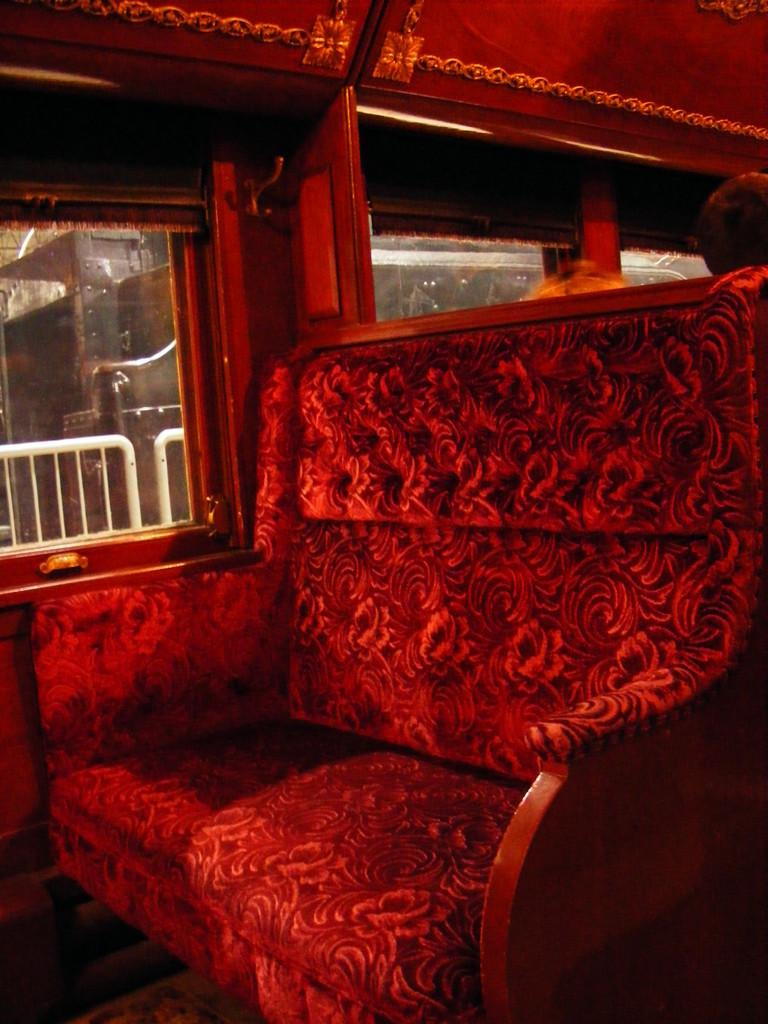What type of furniture is present in the image? There is a sofa in the image. What color is the sofa? The sofa is red in color. What can be seen through the windows in the image? The facts provided do not mention anything about the windows, so we cannot determine what can be seen through them. What type of soup is being served on the red sofa in the image? There is no soup present in the image, and the red sofa is the only furniture mentioned. 